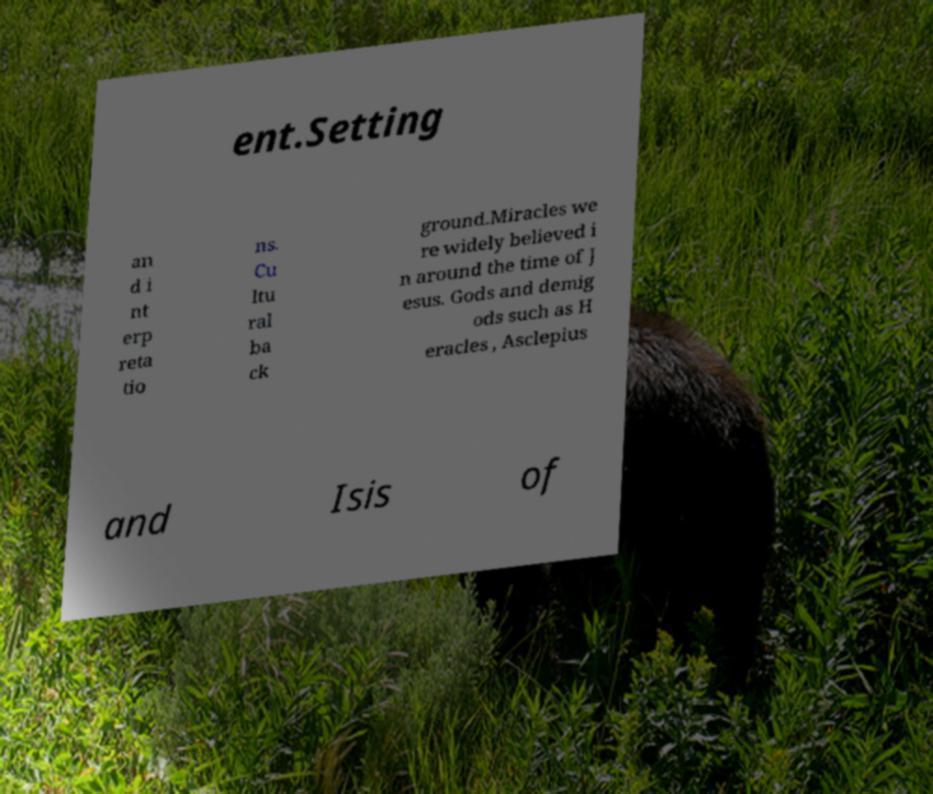Can you accurately transcribe the text from the provided image for me? ent.Setting an d i nt erp reta tio ns. Cu ltu ral ba ck ground.Miracles we re widely believed i n around the time of J esus. Gods and demig ods such as H eracles , Asclepius and Isis of 